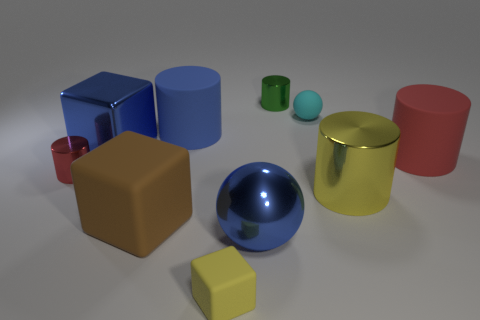Which object stands out most to you and why? The large blue sphere stands out the most due to its high reflectivity and prominent placement in the center of the image, which draws the eye. Its size relative to the other objects also contributes to its dominance in the scene. Do the reflections on the sphere tell us anything about the environment? The reflections on the sphere indicate a diffuse light source above and an environment devoid of distinct features or objects close by. This suggests the scene might be set up in a controlled or minimalistic space, like a photography studio. 